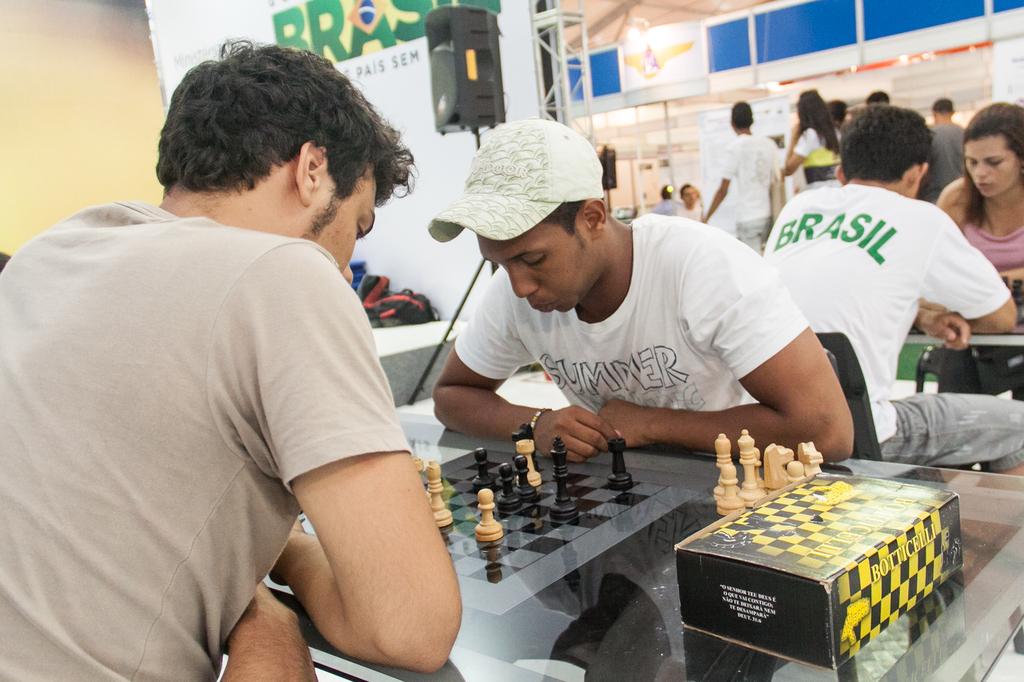What country is on the back of the man's shirt?
Give a very brief answer. Brasil. What country name is on the white shirt?
Give a very brief answer. Brasil. 